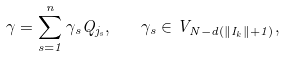Convert formula to latex. <formula><loc_0><loc_0><loc_500><loc_500>\gamma = \sum _ { s = 1 } ^ { n } \gamma _ { s } Q _ { j _ { s } } , \quad \gamma _ { s } \in V _ { N - d ( \| I _ { k } \| + 1 ) } ,</formula> 